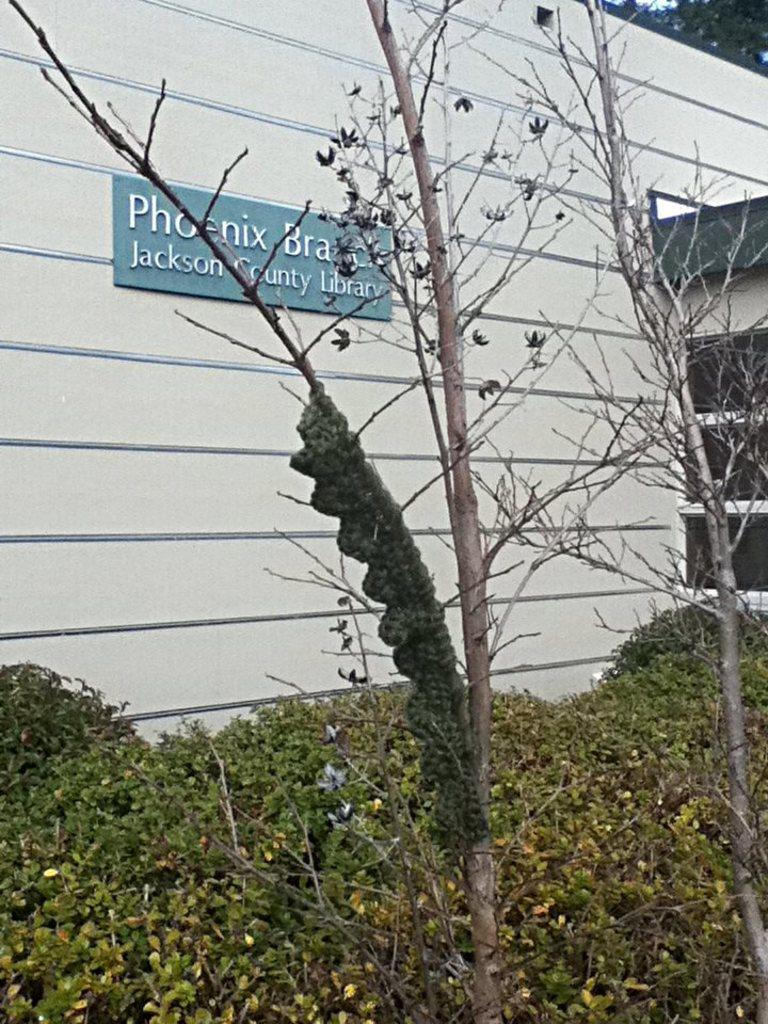What type of living organisms can be seen in the image? Plants and trees are visible in the image. What architectural feature can be seen in the image? There is a glass window and a wall in the image. What direction is the sail facing in the image? There is no sail present in the image. What type of answer can be found in the image? The image does not contain any questions or answers; it features plants, trees, a glass window, and a wall. 